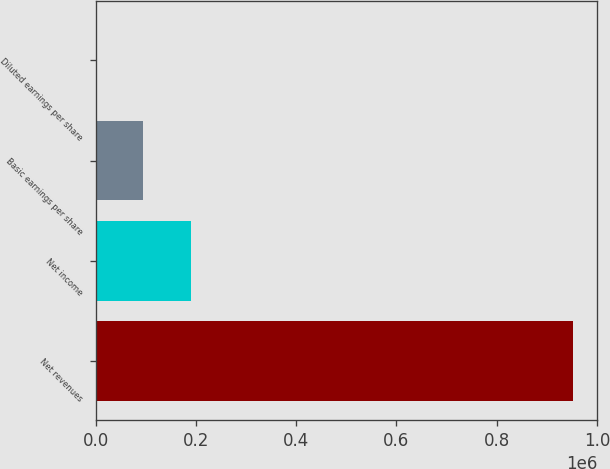Convert chart. <chart><loc_0><loc_0><loc_500><loc_500><bar_chart><fcel>Net revenues<fcel>Net income<fcel>Basic earnings per share<fcel>Diluted earnings per share<nl><fcel>953255<fcel>190652<fcel>95326.1<fcel>0.68<nl></chart> 